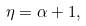<formula> <loc_0><loc_0><loc_500><loc_500>\eta = \alpha + 1 ,</formula> 